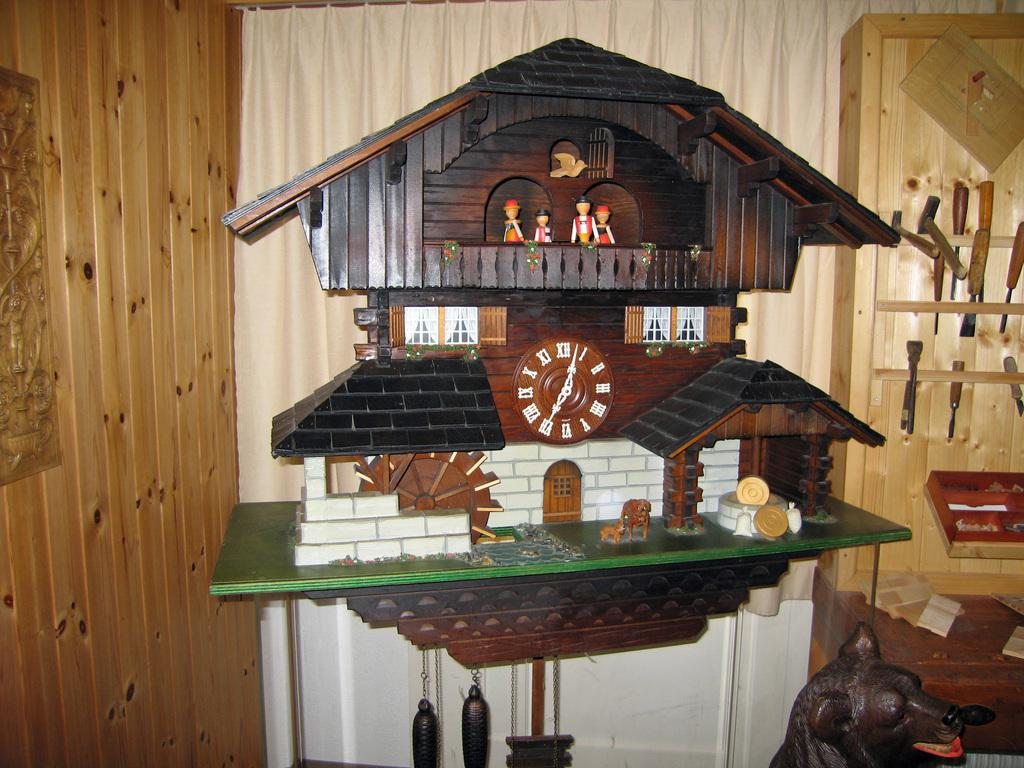<image>
Write a terse but informative summary of the picture. An elaborate coo-coo clock with the time showing 7:02. 